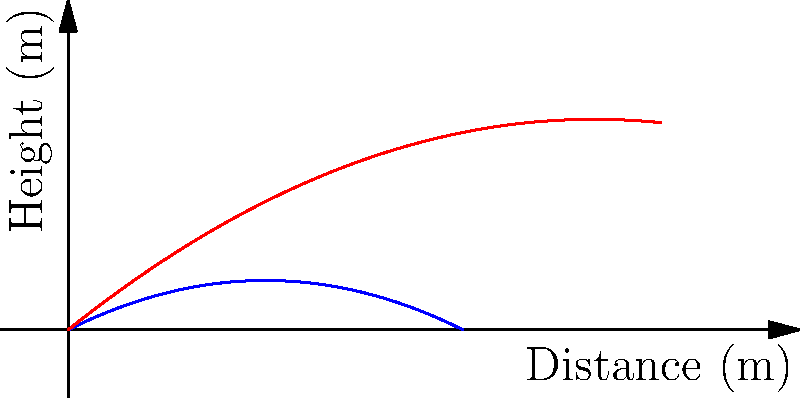As a quarterback, you're analyzing the trajectory of footballs thrown at different angles. The graph shows two paths: one for a ball thrown at a 45° angle (blue) and another at a 60° angle (red). Assuming both throws have the same initial velocity, which angle results in the football traveling a greater horizontal distance before hitting the ground? To determine which throw travels a greater horizontal distance, we need to analyze the trajectories:

1. The 45° throw (blue line):
   - Reaches a lower maximum height
   - Has a steeper parabolic curve
   - Intersects the x-axis (ground) at approximately 10 meters

2. The 60° throw (red line):
   - Reaches a higher maximum height
   - Has a flatter parabolic curve
   - Intersects the x-axis (ground) at approximately 15 meters

3. In projectile motion, the horizontal distance traveled is determined by:
   $$d = \frac{v^2 \sin(2\theta)}{g}$$
   Where $v$ is initial velocity, $\theta$ is the launch angle, and $g$ is gravitational acceleration.

4. For a given initial velocity, the maximum range occurs at a 45° angle. However, air resistance can slightly increase the optimal angle.

5. In this case, the 60° throw clearly travels further horizontally before hitting the ground, contrary to what might be expected in a vacuum.

6. This is due to the effects of air resistance, which can cause higher-angle throws to travel further in real-world conditions, especially for objects like footballs that have significant air resistance.
Answer: 60° angle 